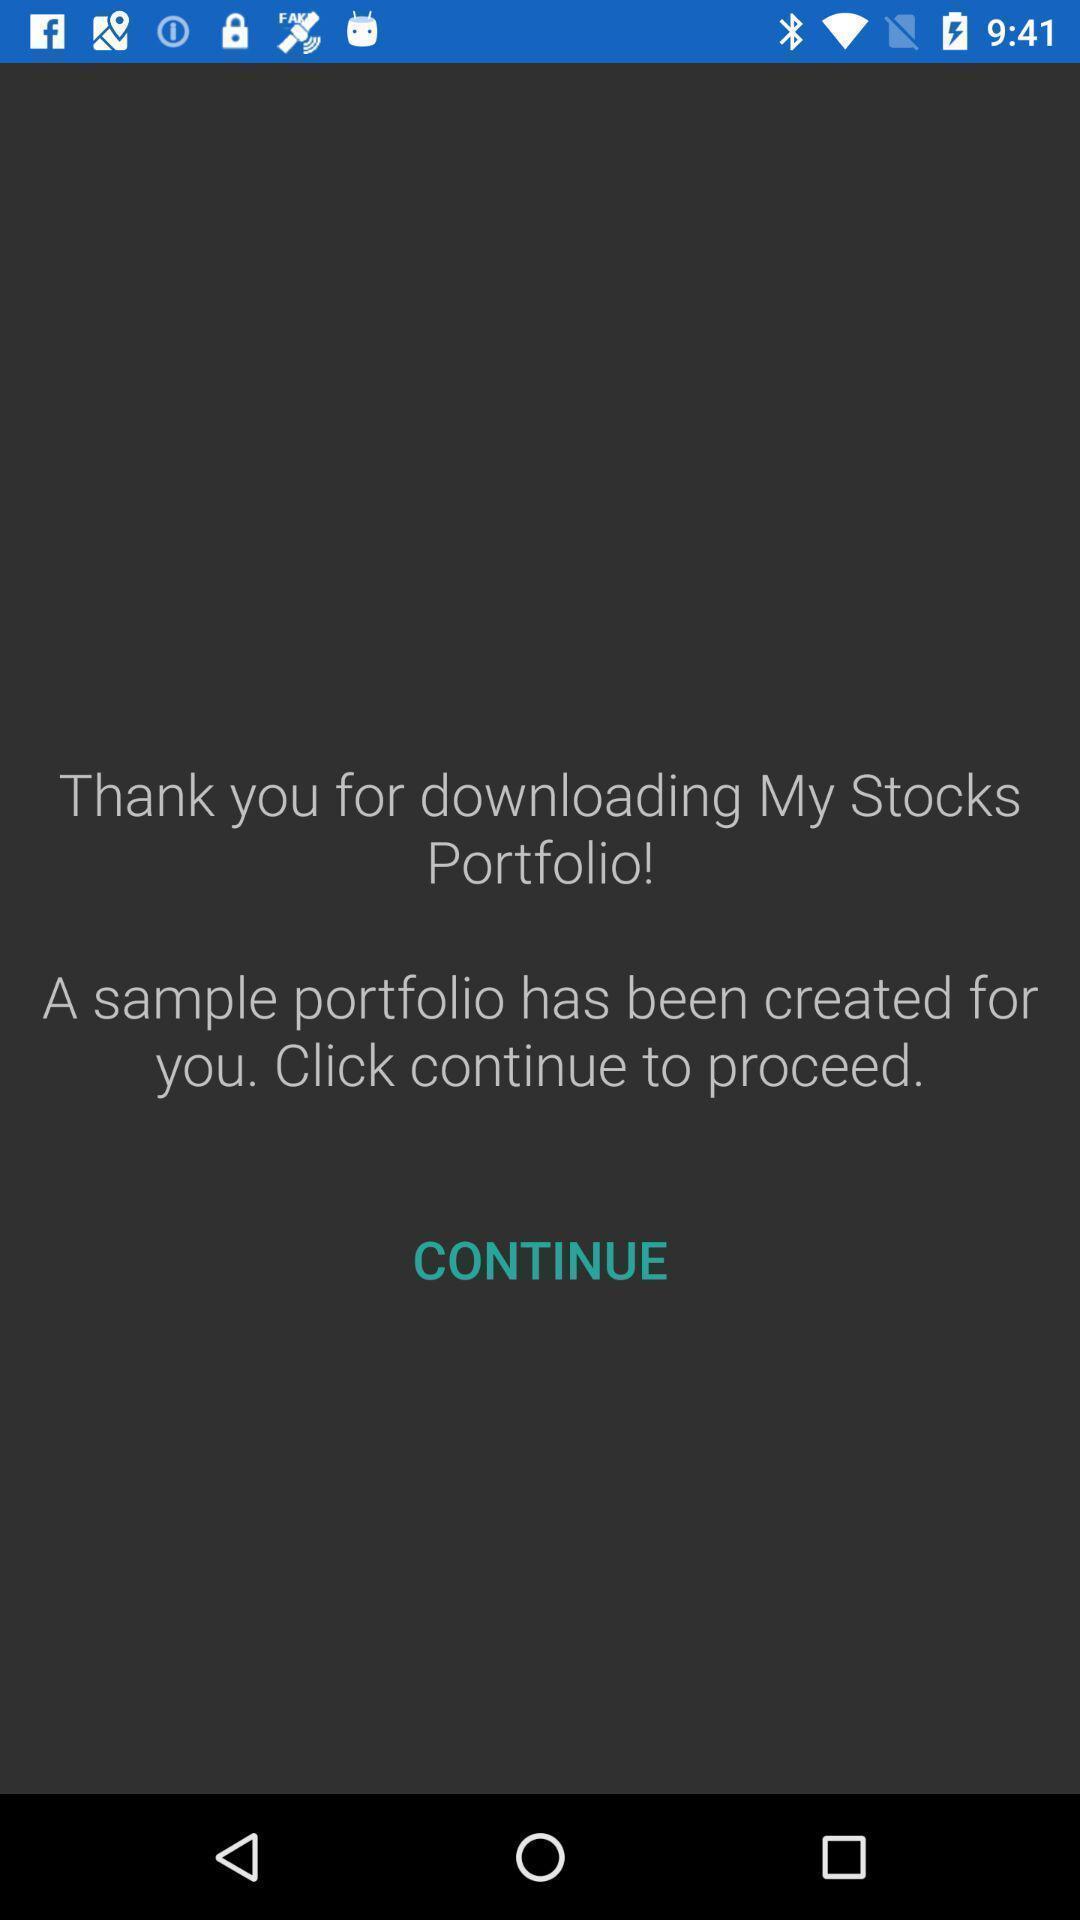Provide a textual representation of this image. Welcome page of a stocks app. 